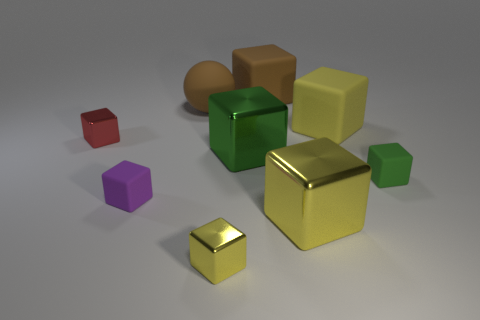The large ball is what color?
Your answer should be compact. Brown. How many other things are there of the same material as the red block?
Provide a succinct answer. 3. What number of red things are tiny metal blocks or big spheres?
Ensure brevity in your answer.  1. There is a large yellow object in front of the small red thing; is it the same shape as the small shiny thing that is in front of the purple rubber thing?
Give a very brief answer. Yes. Does the matte ball have the same color as the small cube that is on the right side of the brown matte cube?
Your answer should be very brief. No. There is a block that is behind the big brown rubber sphere; is its color the same as the big ball?
Offer a very short reply. Yes. How many things are either tiny yellow metallic blocks or rubber things that are on the right side of the large green cube?
Keep it short and to the point. 4. What is the material of the object that is both in front of the big green shiny cube and left of the large matte ball?
Give a very brief answer. Rubber. What is the large yellow thing that is behind the tiny green block made of?
Keep it short and to the point. Rubber. There is a large sphere that is the same material as the brown cube; what color is it?
Your answer should be compact. Brown. 